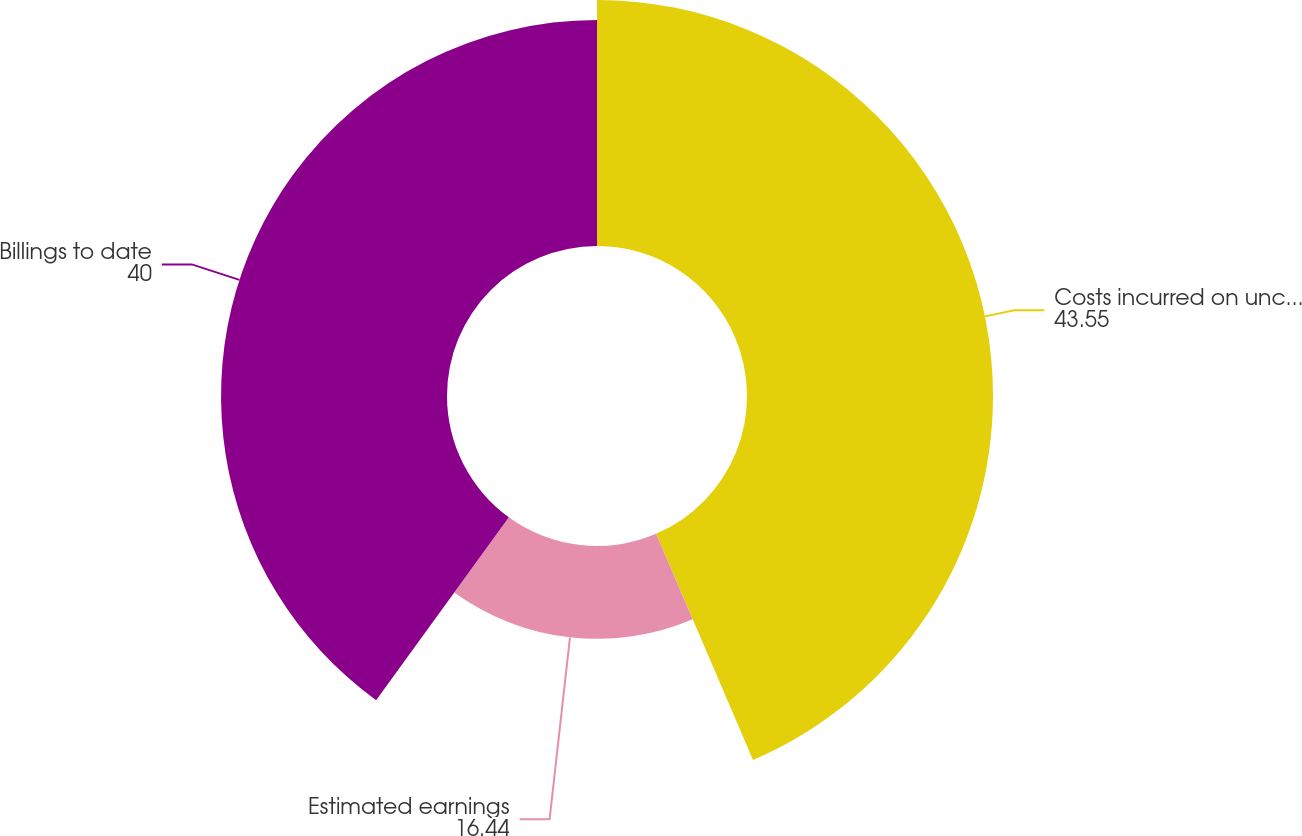Convert chart to OTSL. <chart><loc_0><loc_0><loc_500><loc_500><pie_chart><fcel>Costs incurred on uncompleted<fcel>Estimated earnings<fcel>Billings to date<nl><fcel>43.55%<fcel>16.44%<fcel>40.0%<nl></chart> 